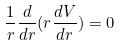Convert formula to latex. <formula><loc_0><loc_0><loc_500><loc_500>\frac { 1 } { r } \frac { d } { d r } ( r \frac { d V } { d r } ) = 0</formula> 